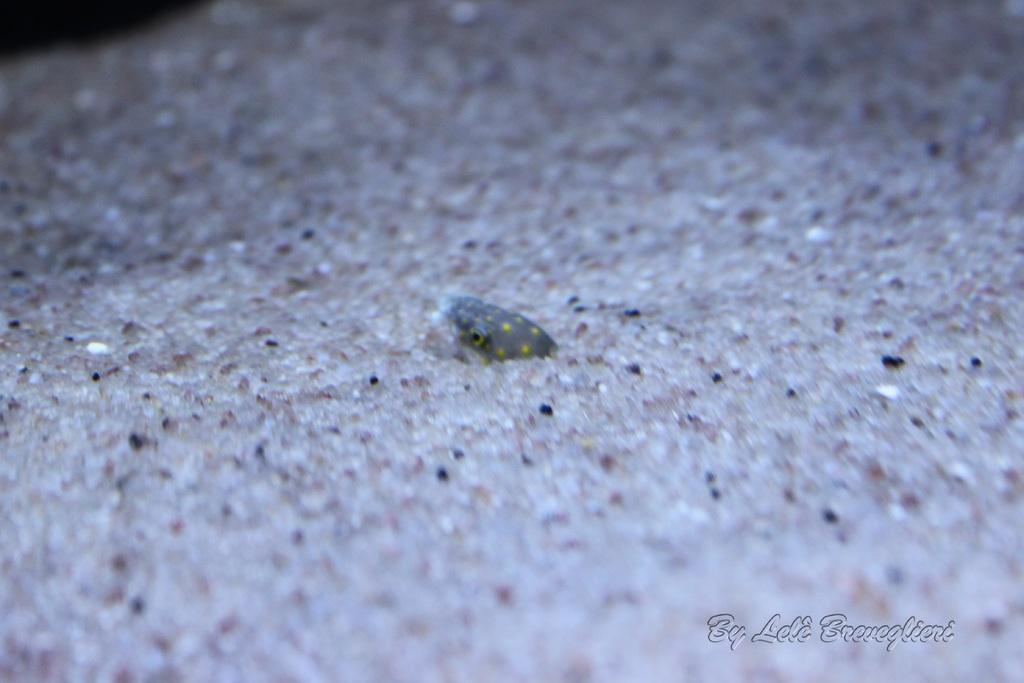What is located in the center of the image? There might be a snake in the center of the image. What type of terrain is visible at the bottom of the image? There is sand at the bottom of the image. What can be found at the bottom of the image besides sand? There is text at the bottom of the image. What type of cub can be seen playing with a rat in the image? There is no cub or rat present in the image; it only mentions a possible snake and sand terrain. 